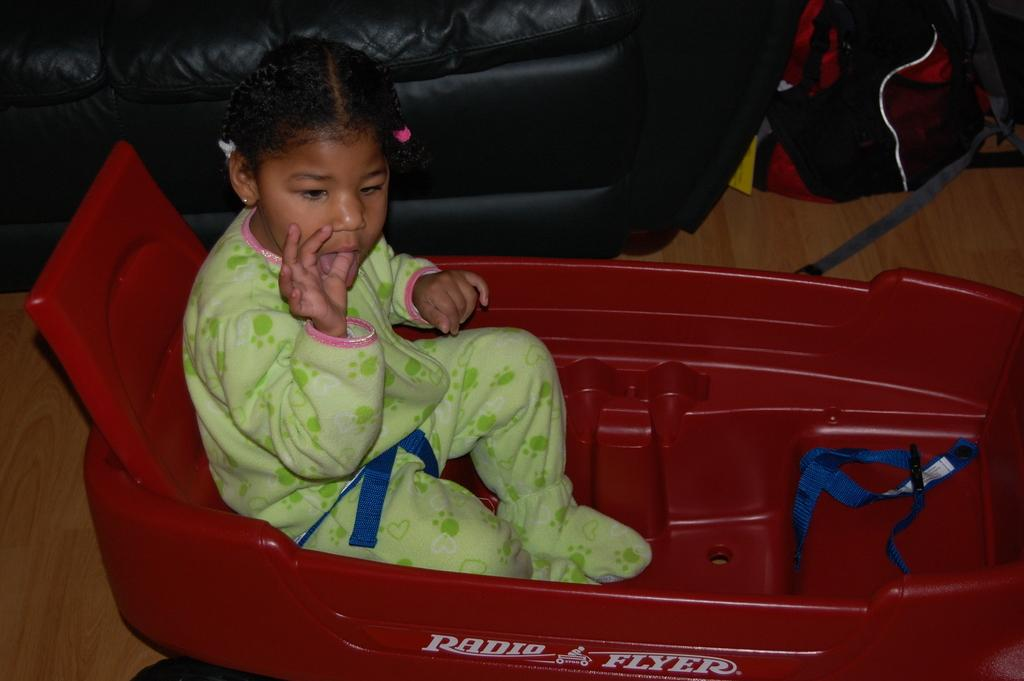What is the main subject in the center of the image? There is a kid on a grow ride in the center of the image. What can be seen in the background of the image? There is a sofa and a bag visible in the background of the image. What is present at the bottom of the image? The floor is present at the bottom of the image. How many houses are visible in the image? There are no houses visible in the image. What type of iron is being used by the kid on the grow ride? There is no iron present in the image; it features a kid on a grow ride. 